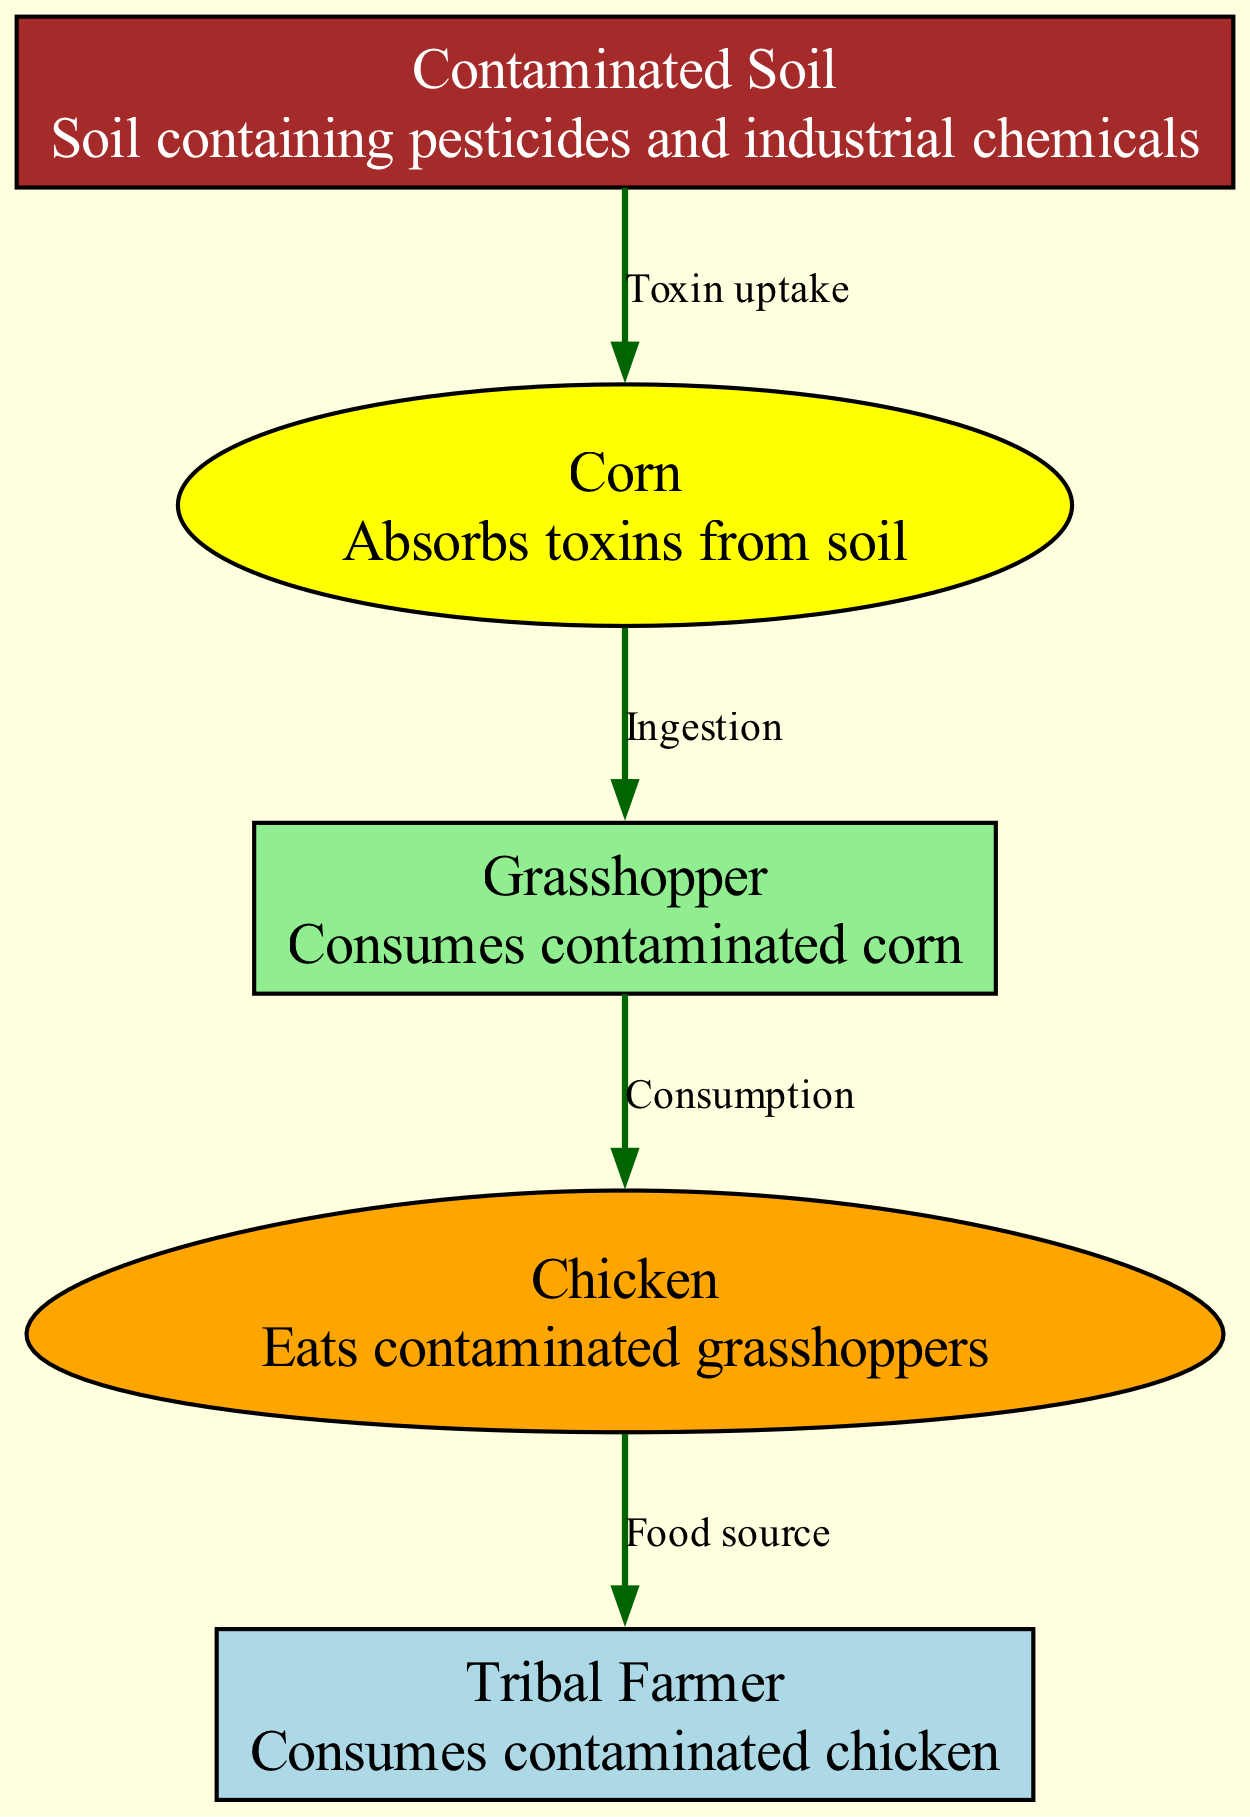What is the first node in the bioaccumulation process? The first node is "Contaminated Soil," which is the starting point of the diagram. It represents the source of toxins that enter the food chain.
Answer: Contaminated Soil How many total nodes are depicted in the diagram? There are five nodes in the diagram: Contaminated Soil, Corn, Grasshopper, Chicken, and Tribal Farmer.
Answer: 5 What happens to corn in the bioaccumulation process? Corn absorbs toxins from the contaminated soil, which establishes its role in the food chain as a plant that takes up pollutants.
Answer: Toxin uptake Which node consumes the grasshopper? The Chicken node consumes the Grasshopper, indicating a predatory relationship within the food chain.
Answer: Chicken What is the relationship between the human and the chicken? The relationship is defined as a food source, where the human, represented as a Tribal Farmer, consumes the chicken as part of their diet.
Answer: Food source How many edges are there connecting the nodes? The diagram contains four edges that depict the connections between the nodes, showing the flow of bioaccumulation from one organism to another.
Answer: 4 What is the color representing the corn node? The corn node is colored yellow in the diagram, which distinguishes it visually from the other nodes.
Answer: Yellow Which element in the diagram represents the final consumer? The "Tribal Farmer" represents the final consumer in the bioaccumulation process, highlighting the impact on human health at the end of the food chain.
Answer: Tribal Farmer Which organism directly consumes contaminated corn? The Grasshopper directly consumes the contaminated corn, indicating its role as a primary consumer in the food chain.
Answer: Grasshopper 